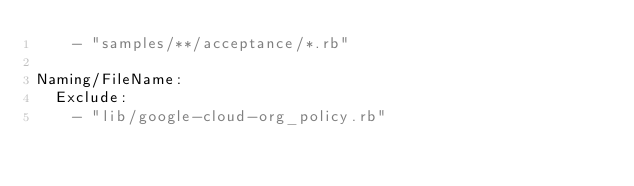Convert code to text. <code><loc_0><loc_0><loc_500><loc_500><_YAML_>    - "samples/**/acceptance/*.rb"

Naming/FileName:
  Exclude:
    - "lib/google-cloud-org_policy.rb"
</code> 